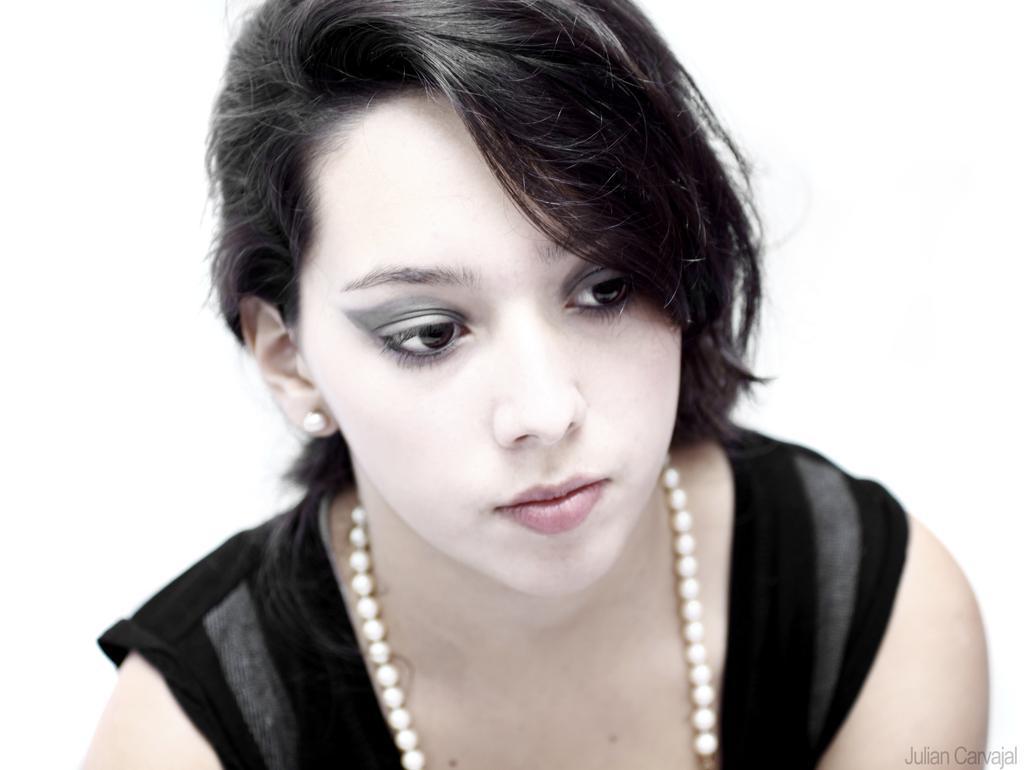Can you describe this image briefly? In this image we can see a woman wearing a black dress. 